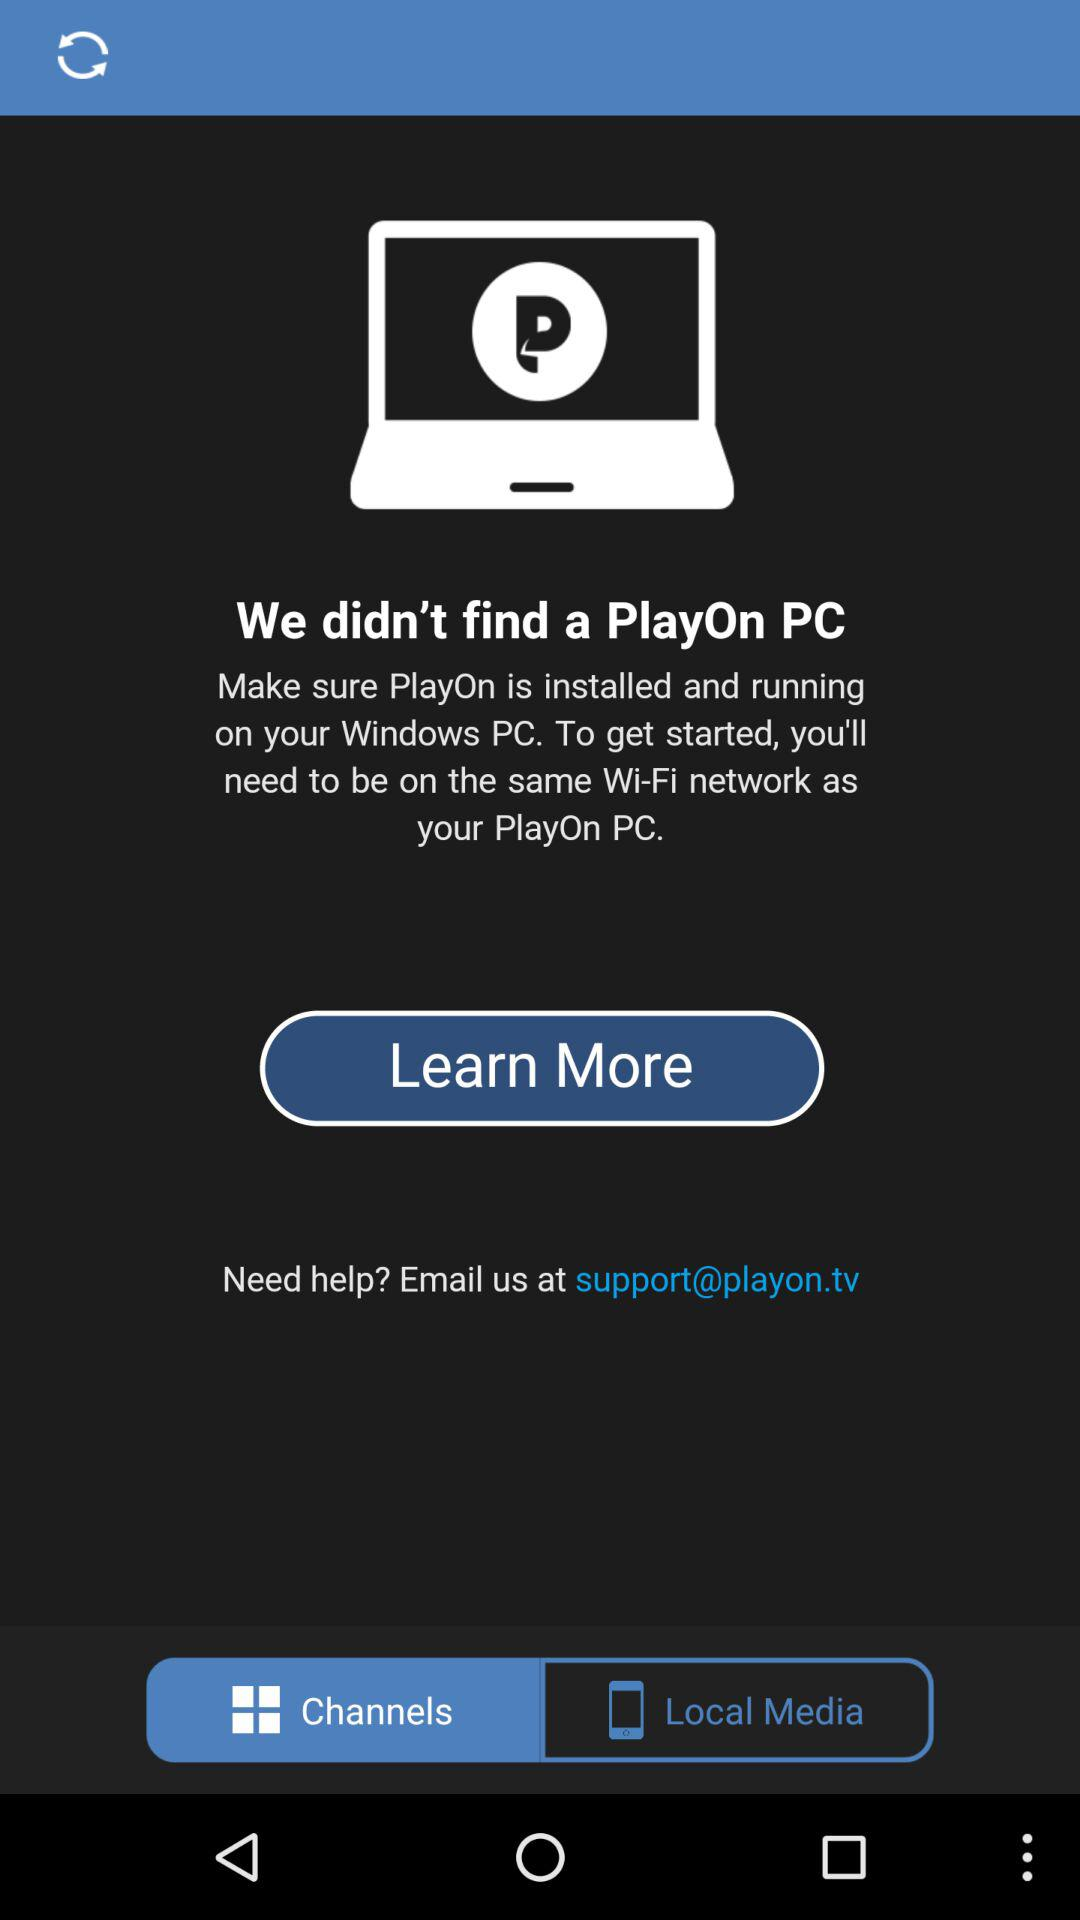What's the given email address for customer help? The given email address for customer help is support@playon.tv. 